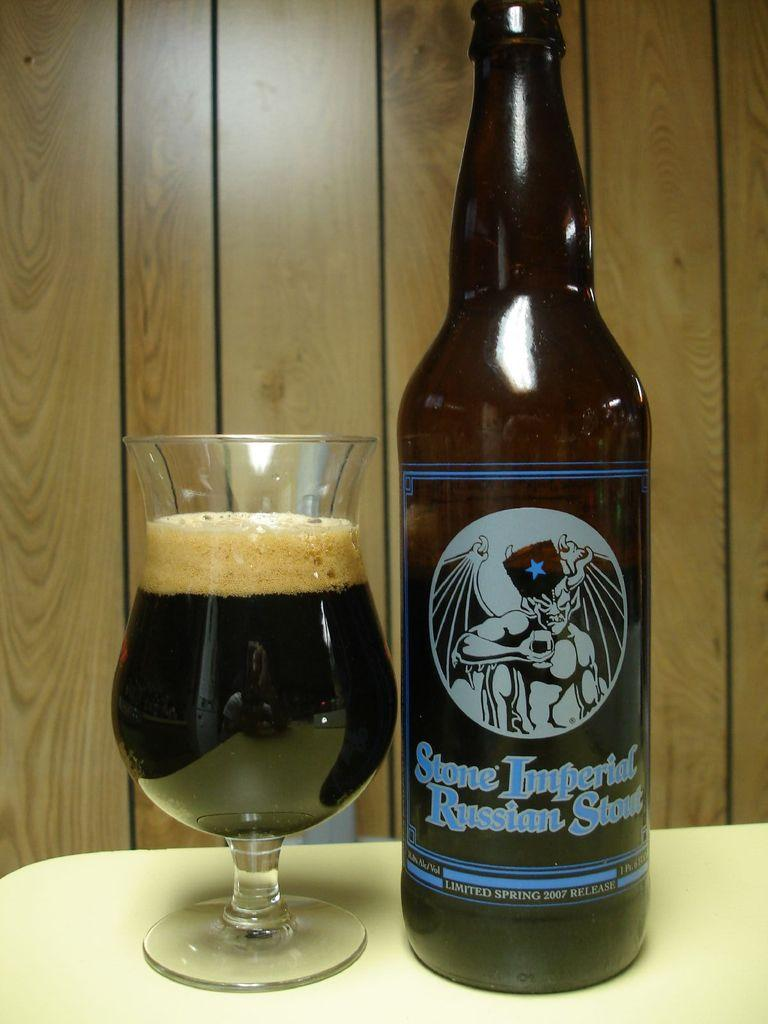Provide a one-sentence caption for the provided image. The label on a bottle of beer says Stone Imperial Russian Stout. 